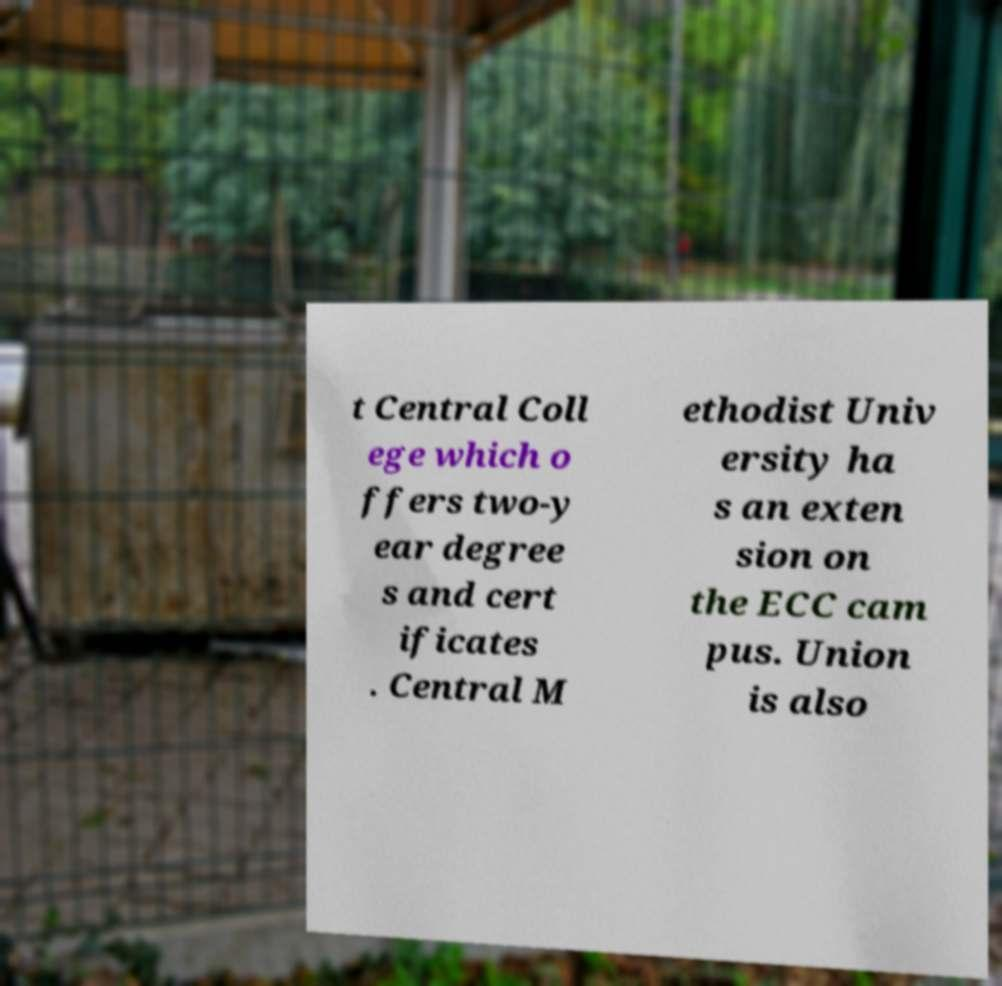Could you assist in decoding the text presented in this image and type it out clearly? t Central Coll ege which o ffers two-y ear degree s and cert ificates . Central M ethodist Univ ersity ha s an exten sion on the ECC cam pus. Union is also 